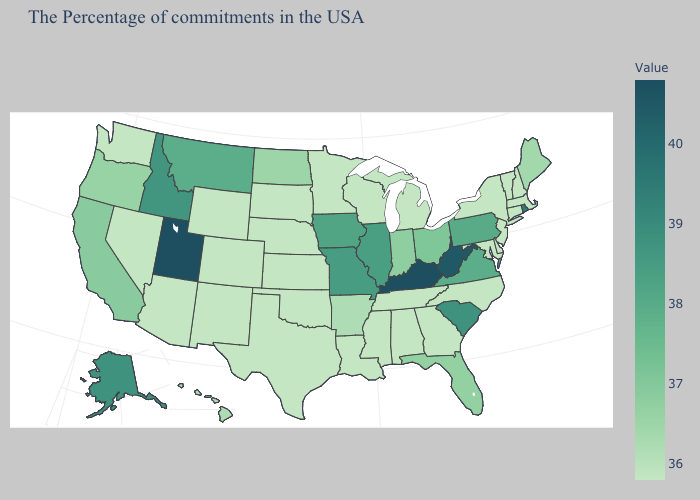Is the legend a continuous bar?
Keep it brief. Yes. Does New Mexico have the lowest value in the West?
Keep it brief. Yes. Does Arizona have the lowest value in the USA?
Concise answer only. Yes. Which states have the highest value in the USA?
Answer briefly. Kentucky, Utah. Does New Mexico have a higher value than California?
Be succinct. No. 